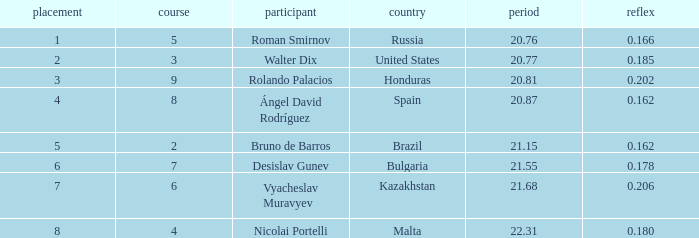What's Brazil's lane with a time less than 21.15? None. Give me the full table as a dictionary. {'header': ['placement', 'course', 'participant', 'country', 'period', 'reflex'], 'rows': [['1', '5', 'Roman Smirnov', 'Russia', '20.76', '0.166'], ['2', '3', 'Walter Dix', 'United States', '20.77', '0.185'], ['3', '9', 'Rolando Palacios', 'Honduras', '20.81', '0.202'], ['4', '8', 'Ángel David Rodríguez', 'Spain', '20.87', '0.162'], ['5', '2', 'Bruno de Barros', 'Brazil', '21.15', '0.162'], ['6', '7', 'Desislav Gunev', 'Bulgaria', '21.55', '0.178'], ['7', '6', 'Vyacheslav Muravyev', 'Kazakhstan', '21.68', '0.206'], ['8', '4', 'Nicolai Portelli', 'Malta', '22.31', '0.180']]} 